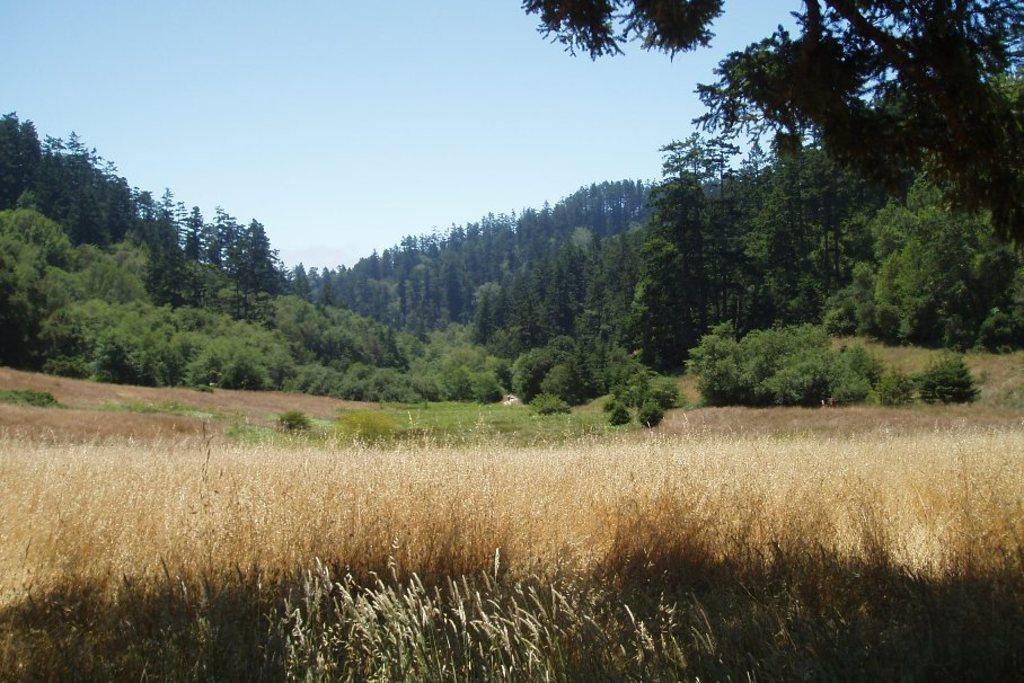Describe this image in one or two sentences. In this picture we can see some grass, few plants and trees in the background. 